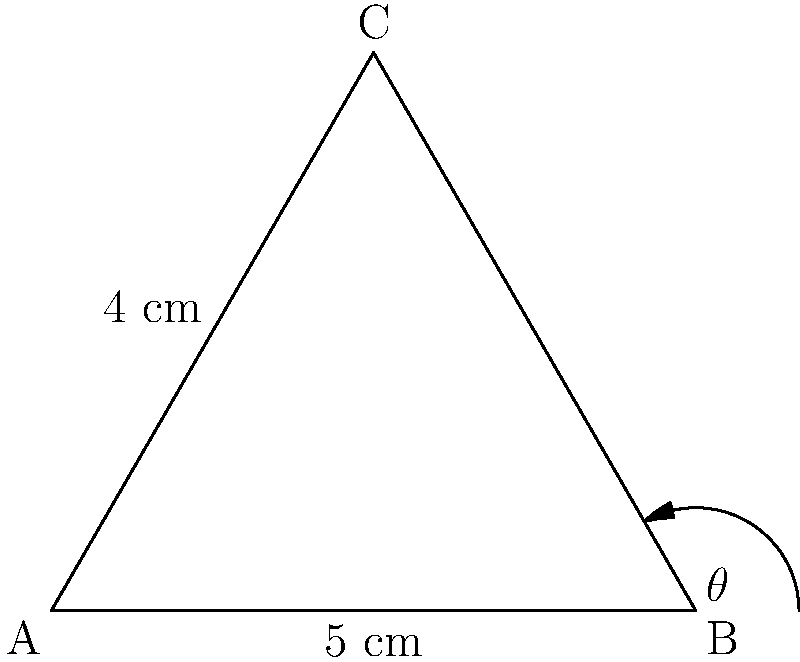In your vintage typewriter, two keys are positioned 5 cm apart. A third key forms an isosceles triangle with these two, with the equal sides measuring 4 cm each. What is the angle $\theta$ (in degrees) between the two 4 cm sides? Let's approach this step-by-step:

1) We have an isosceles triangle where two sides are 4 cm and the base is 5 cm.

2) We can split this isosceles triangle into two right triangles by drawing a perpendicular line from the apex to the base.

3) In one of these right triangles:
   - The hypotenuse is 4 cm
   - Half of the base is 2.5 cm (5 cm ÷ 2)

4) We can use the cosine function to find half of our angle $\theta$:

   $$\cos(\frac{\theta}{2}) = \frac{\text{adjacent}}{\text{hypotenuse}} = \frac{2.5}{4}$$

5) Solving for $\frac{\theta}{2}$:

   $$\frac{\theta}{2} = \arccos(\frac{2.5}{4})$$

6) To get $\theta$, we multiply by 2:

   $$\theta = 2 \arccos(\frac{2.5}{4})$$

7) Using a calculator (or computer):

   $$\theta \approx 2 * 51.32° = 102.64°$$

8) Rounding to the nearest degree:

   $$\theta \approx 103°$$
Answer: 103° 